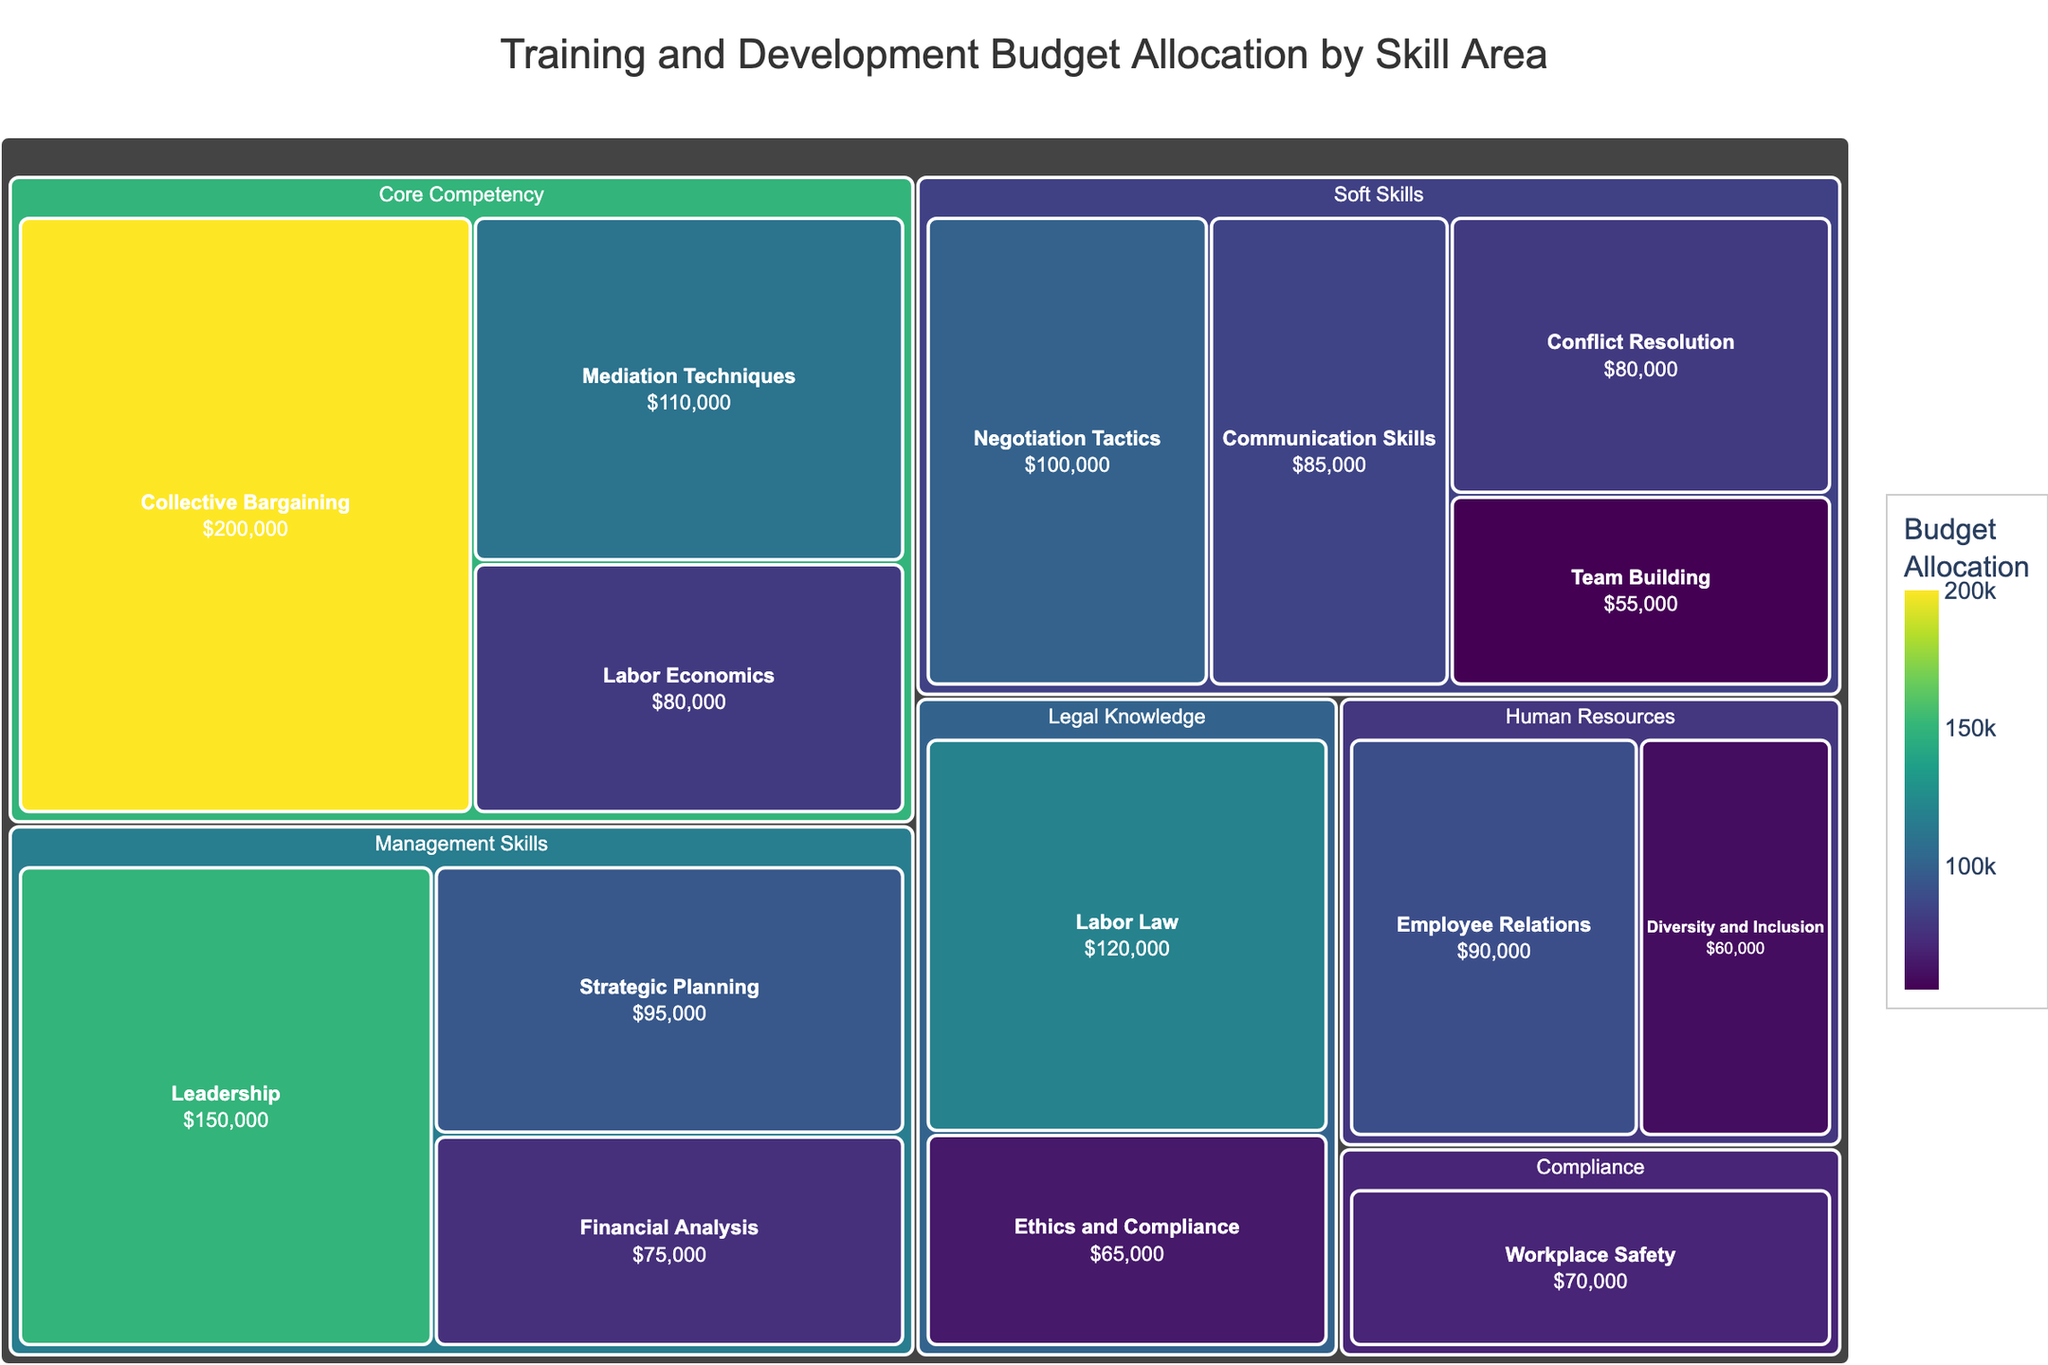What's the total budget allocation for 'Core Competency'? To find the total budget allocation for 'Core Competency', sum up the budget allocations for 'Collective Bargaining', 'Mediation Techniques', and 'Labor Economics': 200,000 + 110,000 + 80,000 = 390,000
Answer: 390,000 Which skill area has the highest budget allocation? Look for the largest value in the figure. 'Collective Bargaining' has the highest budget allocation at 200,000
Answer: Collective Bargaining How much more budget is allocated to 'Conflict Resolution' compared to 'Team Building'? Subtract the budget allocation for 'Team Building' from 'Conflict Resolution': 80,000 - 55,000 = 25,000
Answer: 25,000 Which category has the most skill areas? Count the number of skill areas under each category. 'Soft Skills' has four skill areas: 'Conflict Resolution', 'Negotiation Tactics', 'Communication Skills', and 'Team Building', which is the highest count
Answer: Soft Skills What is the percentage of the total budget allocated to 'Human Resources' compared to the overall budget? First, calculate the total budget across all categories and the total for 'Human Resources', then find the percentage. Total budget: 1,195,000; 'Human Resources': 90,000 + 60,000 = 150,000; (150,000 / 1,195,000) * 100 ≈ 12.55%
Answer: 12.55% Order the categories by budget allocation from highest to lowest. Sum the budget allocations for each category, then order them. 'Core Competency' (390,000), 'Soft Skills' (320,000), 'Management Skills' (320,000), 'Legal Knowledge' (185,000), 'Human Resources' (150,000), 'Compliance' (70,000)
Answer: Core Competency, Soft Skills, Management Skills, Legal Knowledge, Human Resources, Compliance What's the average budget allocation per skill area in 'Management Skills'? Sum the budget allocations for 'Management Skills' and divide by their count. Total: 150,000 + 75,000 + 95,000 = 320,000; Average: 320,000 / 3 ≈ 106,667
Answer: 106,667 Which skill areas have a budget allocation greater than 100,000? Identify skill areas with budget allocations over 100,000 in the figure. These are 'Collective Bargaining', 'Leadership', and 'Mediation Techniques'
Answer: Collective Bargaining, Leadership, Mediation Techniques What is the color representing the lowest budget allocation? Look at the color scale; the lightest color represents the lowest budget, which corresponds to 'Team Building' with 55,000
Answer: light yellow (or similar light color) How does the budget for 'Legal Knowledge' compare to 'Compliance'? Compare the sum of budget allocations from 'Legal Knowledge' and 'Compliance'. 'Legal Knowledge': 120,000 + 65,000 = 185,000; 'Compliance': 70,000. The total for 'Legal Knowledge' (185,000) is greater than 'Compliance' (70,000)
Answer: Legal Knowledge is higher 